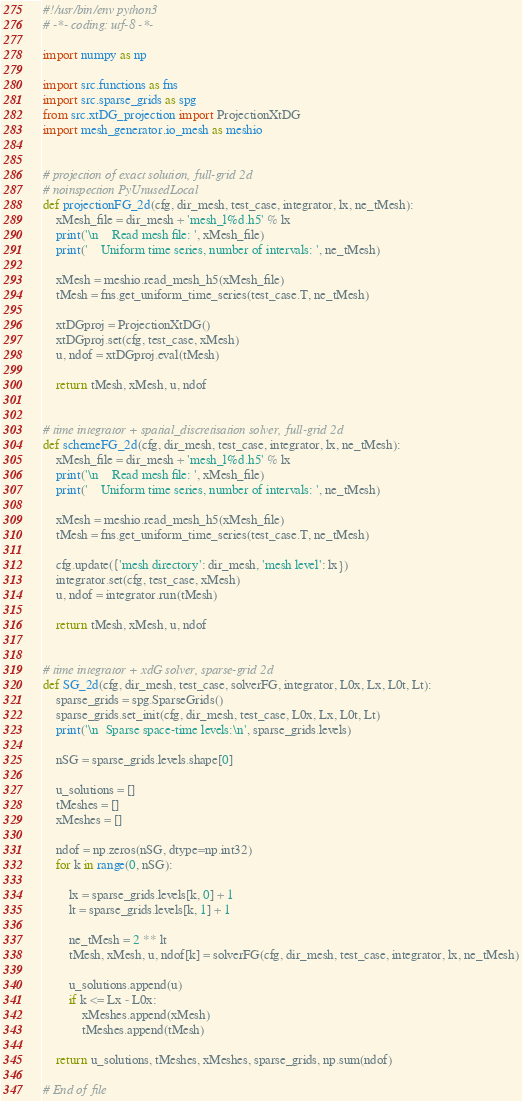<code> <loc_0><loc_0><loc_500><loc_500><_Python_>#!/usr/bin/env python3
# -*- coding: utf-8 -*-

import numpy as np

import src.functions as fns
import src.sparse_grids as spg
from src.xtDG_projection import ProjectionXtDG
import mesh_generator.io_mesh as meshio


# projection of exact solution, full-grid 2d
# noinspection PyUnusedLocal
def projectionFG_2d(cfg, dir_mesh, test_case, integrator, lx, ne_tMesh):
    xMesh_file = dir_mesh + 'mesh_l%d.h5' % lx
    print('\n    Read mesh file: ', xMesh_file)
    print('    Uniform time series, number of intervals: ', ne_tMesh)

    xMesh = meshio.read_mesh_h5(xMesh_file)
    tMesh = fns.get_uniform_time_series(test_case.T, ne_tMesh)

    xtDGproj = ProjectionXtDG()
    xtDGproj.set(cfg, test_case, xMesh)
    u, ndof = xtDGproj.eval(tMesh)

    return tMesh, xMesh, u, ndof


# time integrator + spatial_discretisation solver, full-grid 2d
def schemeFG_2d(cfg, dir_mesh, test_case, integrator, lx, ne_tMesh):
    xMesh_file = dir_mesh + 'mesh_l%d.h5' % lx
    print('\n    Read mesh file: ', xMesh_file)
    print('    Uniform time series, number of intervals: ', ne_tMesh)

    xMesh = meshio.read_mesh_h5(xMesh_file)
    tMesh = fns.get_uniform_time_series(test_case.T, ne_tMesh)

    cfg.update({'mesh directory': dir_mesh, 'mesh level': lx})
    integrator.set(cfg, test_case, xMesh)
    u, ndof = integrator.run(tMesh)

    return tMesh, xMesh, u, ndof


# time integrator + xdG solver, sparse-grid 2d
def SG_2d(cfg, dir_mesh, test_case, solverFG, integrator, L0x, Lx, L0t, Lt):
    sparse_grids = spg.SparseGrids()
    sparse_grids.set_init(cfg, dir_mesh, test_case, L0x, Lx, L0t, Lt)
    print('\n  Sparse space-time levels:\n', sparse_grids.levels)

    nSG = sparse_grids.levels.shape[0]

    u_solutions = []
    tMeshes = []
    xMeshes = []

    ndof = np.zeros(nSG, dtype=np.int32)
    for k in range(0, nSG):

        lx = sparse_grids.levels[k, 0] + 1
        lt = sparse_grids.levels[k, 1] + 1

        ne_tMesh = 2 ** lt
        tMesh, xMesh, u, ndof[k] = solverFG(cfg, dir_mesh, test_case, integrator, lx, ne_tMesh)

        u_solutions.append(u)
        if k <= Lx - L0x:
            xMeshes.append(xMesh)
            tMeshes.append(tMesh)

    return u_solutions, tMeshes, xMeshes, sparse_grids, np.sum(ndof)

# End of file
</code> 